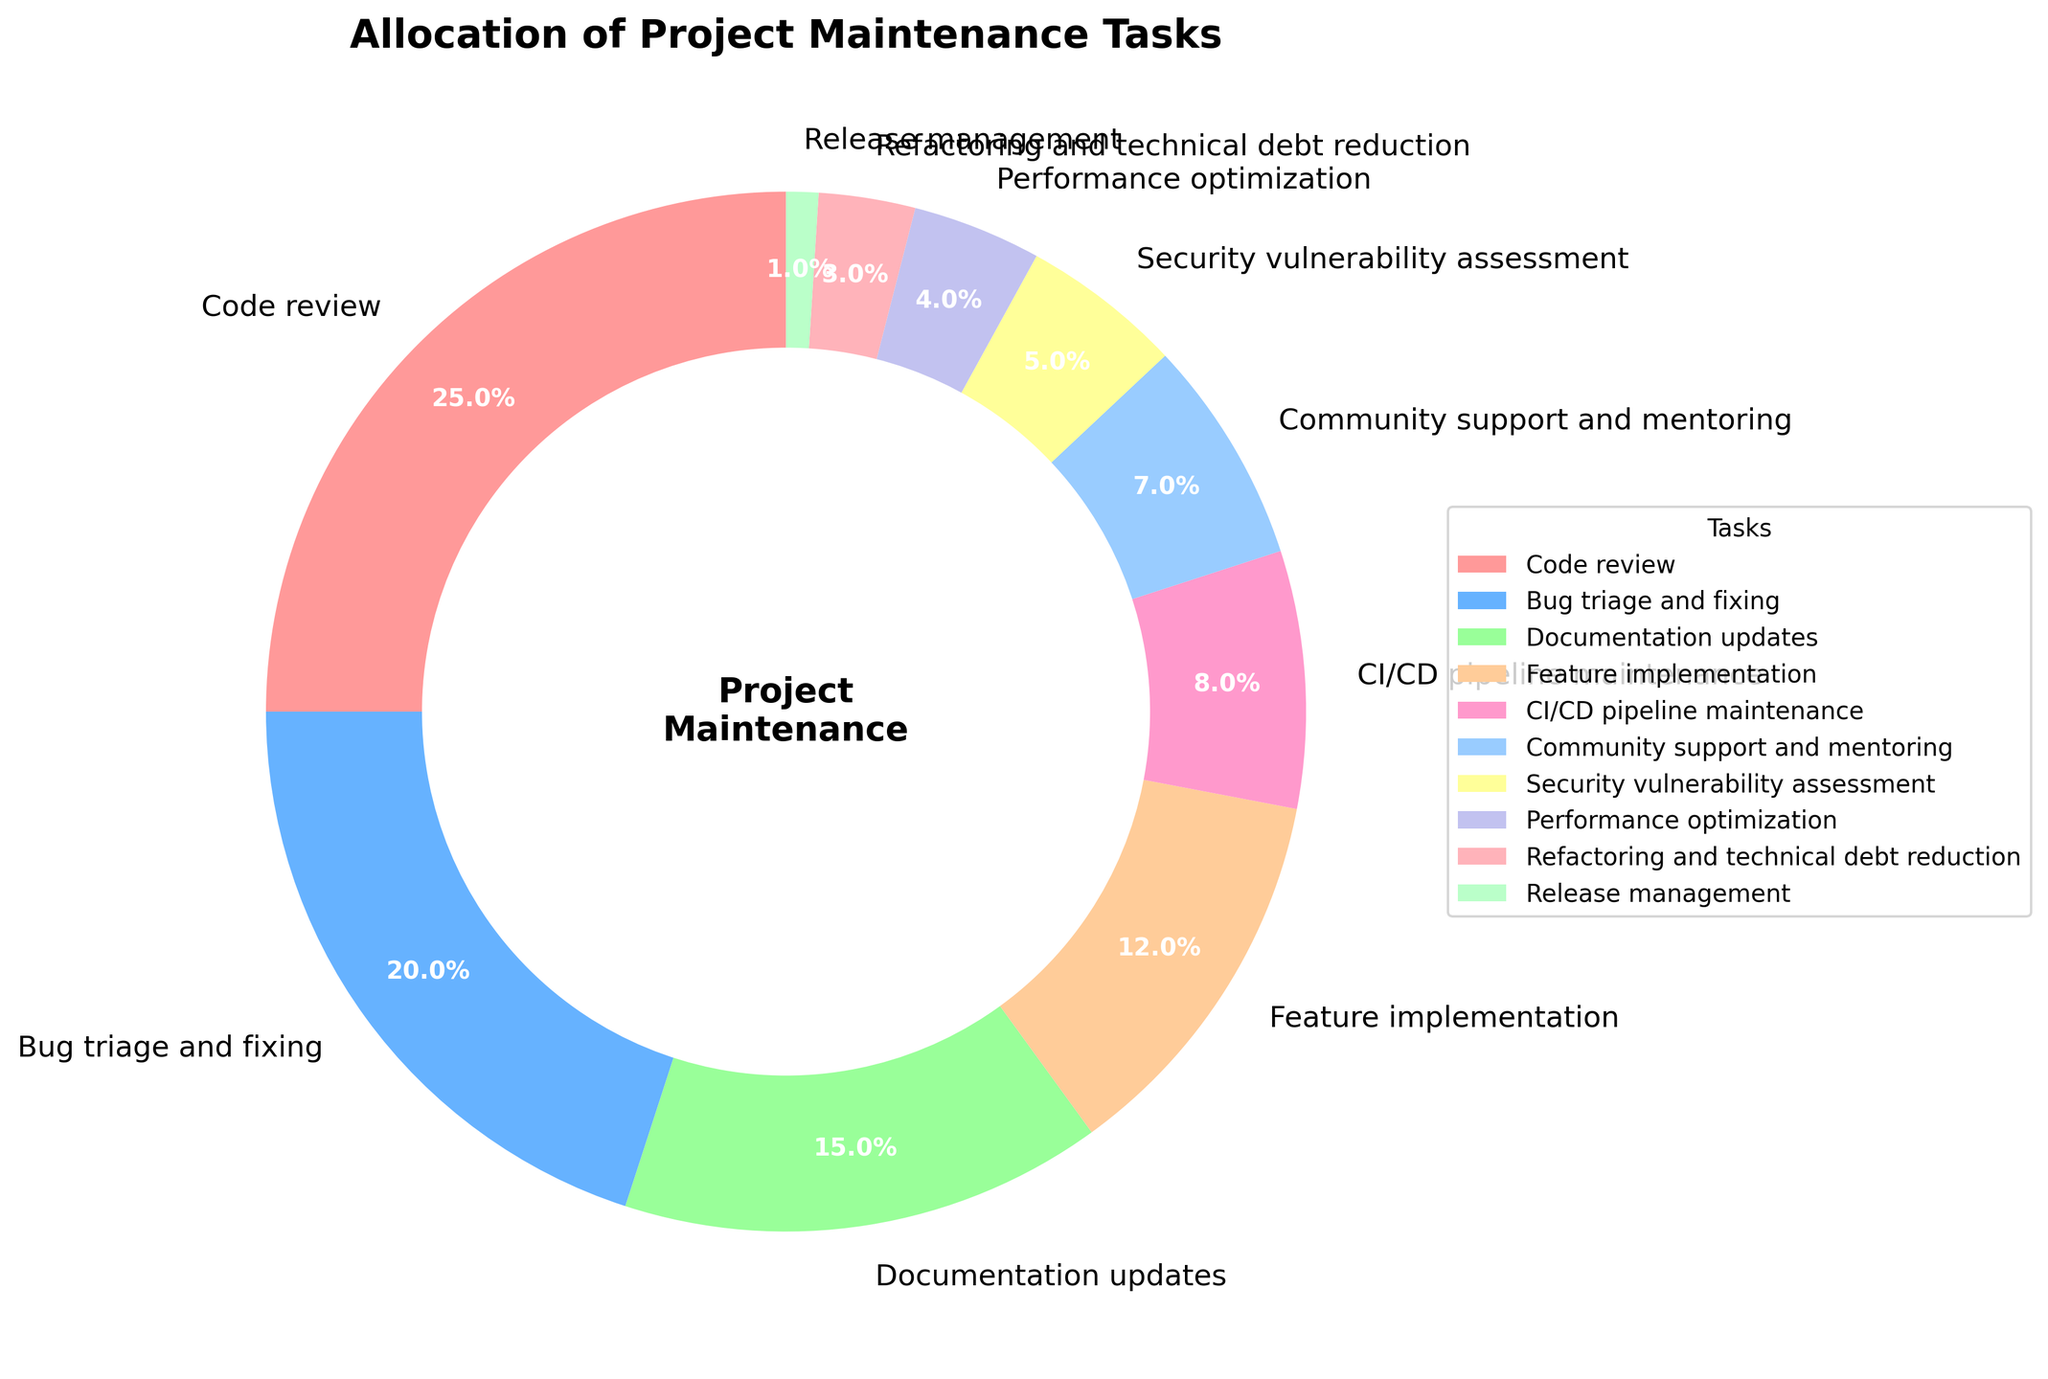Which task consumes the largest percentage of project maintenance efforts? To find the largest percentage, we simply look at the segment of the pie chart that is the largest. From the legend and the visual size, "Code review" is the largest at 25%.
Answer: Code review How does the percentage allocated to Community support and mentoring compare to Documentation updates? Check the legend and the size of the pie chart segments labeled "Community support and mentoring" and "Documentation updates." "Community support and mentoring" is 7%, and "Documentation updates" is 15%, so the latter is significantly larger.
Answer: Documentation updates is larger What's the combined percentage of Bug triage and fixing and Feature implementation? Sum the two percentages: Bug triage and fixing (20%) + Feature implementation (12%) = 32%.
Answer: 32% Which task has the least allocation, and what is its percentage? Identify the smallest segment in the pie chart, which the legend indicates is "Release management" at 1%.
Answer: Release management, 1% Compare the allocations for CI/CD pipeline maintenance and Performance optimization. Which is greater and by how much? CI/CD pipeline maintenance is 8% and Performance optimization is 4%. The difference is 8% - 4% = 4%.
Answer: CI/CD pipeline maintenance by 4% If you combine the percentages for Refactoring and technical debt reduction, Security vulnerability assessment, and Release management, what is the total? Sum the percentages: Refactoring and technical debt reduction (3%) + Security vulnerability assessment (5%) + Release management (1%) = 9%.
Answer: 9% How much more percentage is allocated to Bug triage and fixing compared to Security vulnerability assessment? Subtract the percentage for Security vulnerability assessment from Bug triage and fixing: 20% - 5% = 15%.
Answer: 15% What's the second largest task allocation? The largest allocation is "Code review" at 25%. The next largest is "Bug triage and fixing" at 20%.
Answer: Bug triage and fixing 